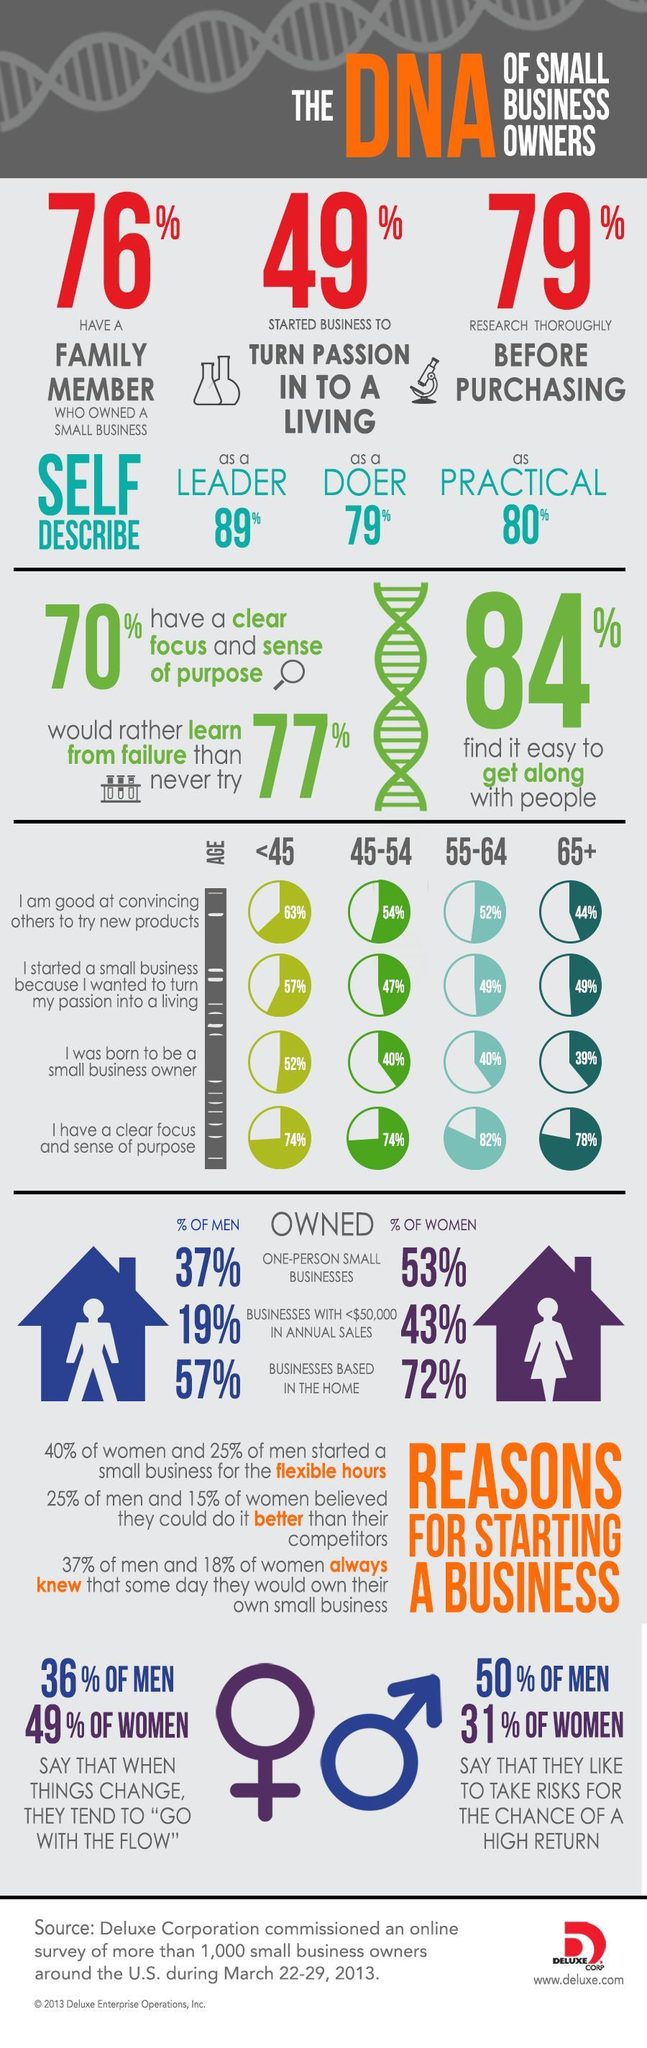What percent of the small business owners research thoroughly before purchasing according to the survey?
Answer the question with a short phrase. 79% What percent of the small business owners aged 65+ years in the U.S. think that they are good at convincing others to try new products as per the survey? 44% What percent of the small business owners aged under 45 years think that they were born to be a small business owner as per the survey? 52% What percentage of the men in the U.S. say that they like to take risks for the chance of a high return as per the survey? 50% What percentage of women in the U.S. owned businesses based at home as per the survey? 72% What percentage of men in the U.S. owned businesses with less than $50,000 annual sales as per the survey? 19% What percent of the small business owners aged 45-54 years in the U.S. think that they have a clear focus & sense of purpose as per the survey? 74% 